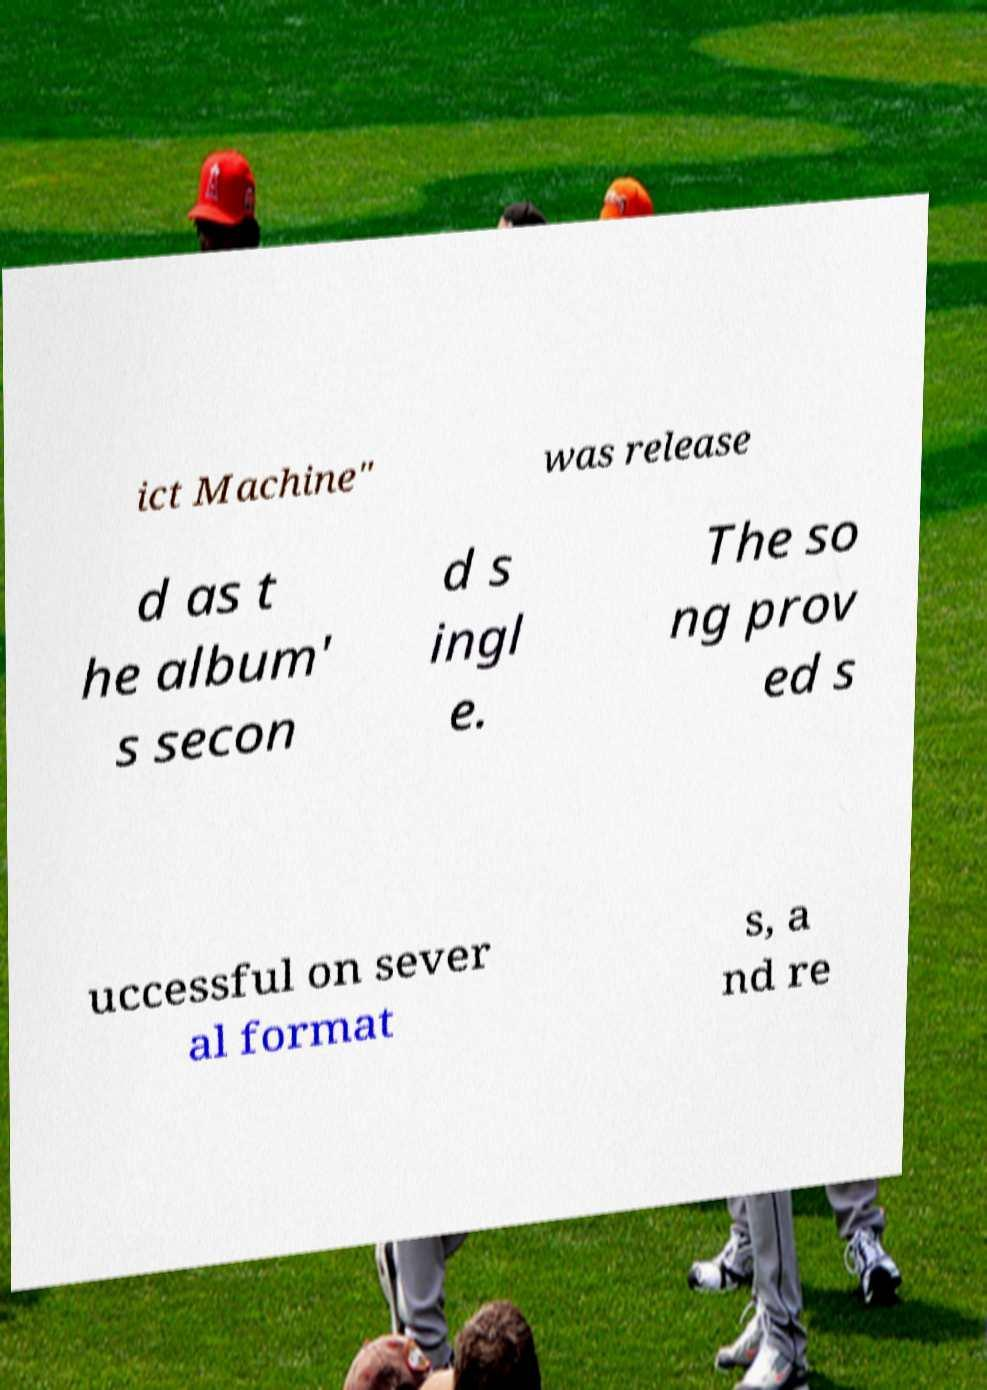For documentation purposes, I need the text within this image transcribed. Could you provide that? ict Machine" was release d as t he album' s secon d s ingl e. The so ng prov ed s uccessful on sever al format s, a nd re 